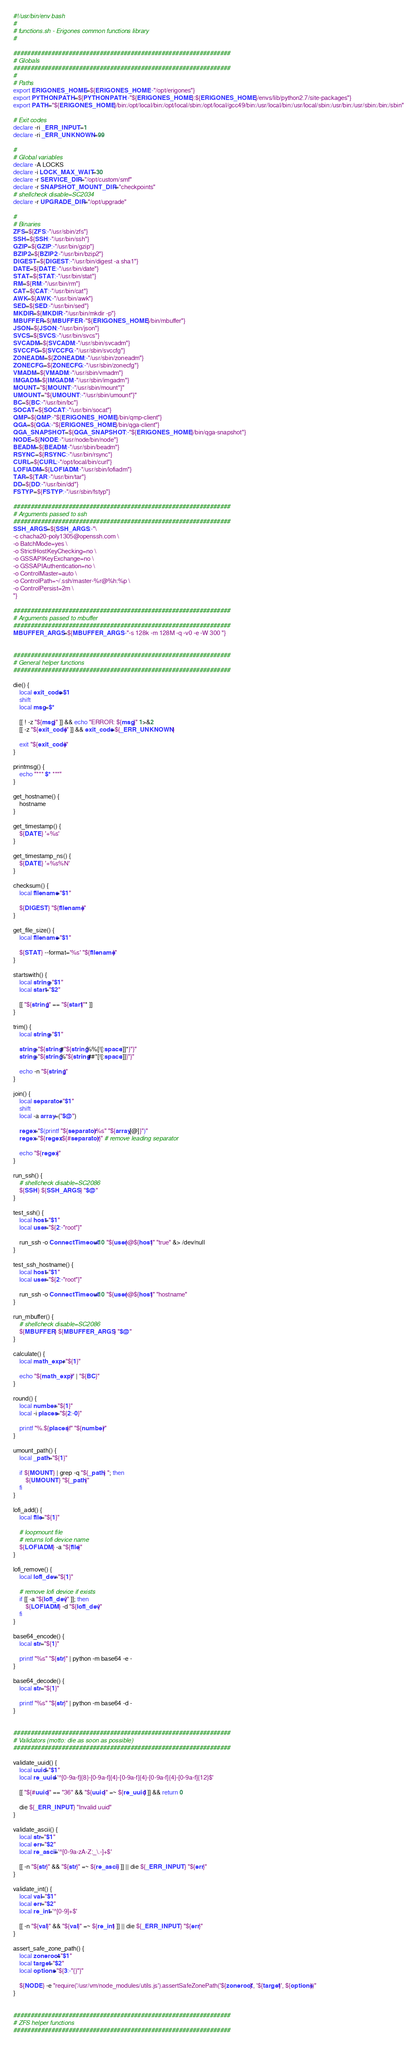<code> <loc_0><loc_0><loc_500><loc_500><_Bash_>#!/usr/bin/env bash
#
# functions.sh - Erigones common functions library
#

###############################################################
# Globals
###############################################################
#
# Paths
export ERIGONES_HOME=${ERIGONES_HOME:-"/opt/erigones"}
export PYTHONPATH=${PYTHONPATH:-"${ERIGONES_HOME}:${ERIGONES_HOME}/envs/lib/python2.7/site-packages"}
export PATH="${ERIGONES_HOME}/bin:/opt/local/bin:/opt/local/sbin:/opt/local/gcc49/bin:/usr/local/bin:/usr/local/sbin:/usr/bin:/usr/sbin:/bin:/sbin"

# Exit codes
declare -ri _ERR_INPUT=1
declare -ri _ERR_UNKNOWN=99

#
# Global variables
declare -A LOCKS
declare -i LOCK_MAX_WAIT=30
declare -r SERVICE_DIR="/opt/custom/smf"
declare -r SNAPSHOT_MOUNT_DIR="checkpoints"
# shellcheck disable=SC2034
declare -r UPGRADE_DIR="/opt/upgrade"

#
# Binaries
ZFS=${ZFS:-"/usr/sbin/zfs"}
SSH=${SSH:-"/usr/bin/ssh"}
GZIP=${GZIP:-"/usr/bin/gzip"}
BZIP2=${BZIP2:-"/usr/bin/bzip2"}
DIGEST=${DIGEST:-"/usr/bin/digest -a sha1"}
DATE=${DATE:-"/usr/bin/date"}
STAT=${STAT:-"/usr/bin/stat"}
RM=${RM:-"/usr/bin/rm"}
CAT=${CAT:-"/usr/bin/cat"}
AWK=${AWK:-"/usr/bin/awk"}
SED=${SED:-"/usr/bin/sed"}
MKDIR=${MKDIR:-"/usr/bin/mkdir -p"}
MBUFFER=${MBUFFER:-"${ERIGONES_HOME}/bin/mbuffer"}
JSON=${JSON:-"/usr/bin/json"}
SVCS=${SVCS:-"/usr/bin/svcs"}
SVCADM=${SVCADM:-"/usr/sbin/svcadm"}
SVCCFG=${SVCCFG:-"/usr/sbin/svccfg"}
ZONEADM=${ZONEADM:-"/usr/sbin/zoneadm"}
ZONECFG=${ZONECFG:-"/usr/sbin/zonecfg"}
VMADM=${VMADM:-"/usr/sbin/vmadm"}
IMGADM=${IMGADM:-"/usr/sbin/imgadm"}
MOUNT="${MOUNT:-"/usr/sbin/mount"}"
UMOUNT="${UMOUNT:-"/usr/sbin/umount"}"
BC=${BC:-"/usr/bin/bc"}
SOCAT=${SOCAT:-"/usr/bin/socat"}
QMP=${QMP:-"${ERIGONES_HOME}/bin/qmp-client"}
QGA=${QGA:-"${ERIGONES_HOME}/bin/qga-client"}
QGA_SNAPSHOT=${QGA_SNAPSHOT:-"${ERIGONES_HOME}/bin/qga-snapshot"}
NODE=${NODE:-"/usr/node/bin/node"}
BEADM=${BEADM:-"/usr/sbin/beadm"}
RSYNC=${RSYNC:-"/usr/bin/rsync"}
CURL=${CURL:-"/opt/local/bin/curl"}
LOFIADM=${LOFIADM:-"/usr/sbin/lofiadm"}
TAR=${TAR:-"/usr/bin/tar"}
DD=${DD:-"/usr/bin/dd"}
FSTYP=${FSTYP:-"/usr/sbin/fstyp"}

###############################################################
# Arguments passed to ssh
###############################################################
SSH_ARGS=${SSH_ARGS:-"\
-c chacha20-poly1305@openssh.com \
-o BatchMode=yes \
-o StrictHostKeyChecking=no \
-o GSSAPIKeyExchange=no \
-o GSSAPIAuthentication=no \
-o ControlMaster=auto \
-o ControlPath=~/.ssh/master-%r@%h:%p \
-o ControlPersist=2m \
"}

###############################################################
# Arguments passed to mbuffer
###############################################################
MBUFFER_ARGS=${MBUFFER_ARGS:-"-s 128k -m 128M -q -v0 -e -W 300 "}


###############################################################
# General helper functions
###############################################################

die() {
	local exit_code=$1
	shift
	local msg=$*

	[[ ! -z "${msg}" ]] && echo "ERROR: ${msg}" 1>&2
	[[ -z "${exit_code}" ]] && exit_code=${_ERR_UNKNOWN}

	exit "${exit_code}"
}

printmsg() {
	echo "*** $* ***"
}

get_hostname() {
	hostname
}

get_timestamp() {
	${DATE} '+%s'
}

get_timestamp_ns() {
	${DATE} '+%s%N'
}

checksum() {
	local filename="$1"

	${DIGEST} "${filename}"
}

get_file_size() {
	local filename="$1"

	${STAT} --format='%s' "${filename}"
}

startswith() {
	local string="$1"
	local start="$2"

	[[ "${string}" == "${start}"* ]]
}

trim() {
	local string="$1"

	string="${string#"${string%%[![:space:]]*}"}"
	string="${string%"${string##*[![:space:]]}"}"

	echo -n "${string}"
}

join() {
	local separator="$1"
	shift
	local -a array=("$@")

	regex="$(printf "${separator}%s" "${array[@]}")"
	regex="${regex:${#separator}}" # remove leading separator

	echo "${regex}"
}

run_ssh() {
	# shellcheck disable=SC2086
	${SSH} ${SSH_ARGS} "$@"
}

test_ssh() {
	local host="$1"
	local user="${2:-"root"}"

	run_ssh -o ConnectTimeout=10 "${user}@${host}" "true" &> /dev/null
}

test_ssh_hostname() {
	local host="$1"
	local user="${2:-"root"}"

	run_ssh -o ConnectTimeout=10 "${user}@${host}" "hostname"
}

run_mbuffer() {
	# shellcheck disable=SC2086
	${MBUFFER} ${MBUFFER_ARGS} "$@"
}

calculate() {
	local math_expr="${1}"

	echo "${math_expr}" | "${BC}"
}

round() {
	local number="${1}"
	local -i places="${2:-0}"

	printf "%.${places}f" "${number}"
}

umount_path() {
	local _path="${1}"

	if ${MOUNT} | grep -q "${_path} "; then
		${UMOUNT} "${_path}"
	fi
}

lofi_add() {
	local file="${1}"

	# loopmount file
	# returns lofi device name
	${LOFIADM} -a "${file}"
}

lofi_remove() {
	local lofi_dev="${1}"

	# remove lofi device if exists
	if [[ -a "${lofi_dev}" ]]; then
		${LOFIADM} -d "${lofi_dev}"
	fi
}

base64_encode() {
	local str="${1}"

	printf "%s" "${str}" | python -m base64 -e -
}

base64_decode() {
	local str="${1}"

	printf "%s" "${str}" | python -m base64 -d -
}


###############################################################
# Validators (motto: die as soon as possible)
###############################################################

validate_uuid() {  
	local uuid="$1"
	local re_uuid='^[0-9a-f]{8}-[0-9a-f]{4}-[0-9a-f]{4}-[0-9a-f]{4}-[0-9a-f]{12}$'

	[[ "${#uuid}" == "36" && "${uuid}" =~ ${re_uuid} ]] && return 0

	die ${_ERR_INPUT} "Invalid uuid"
}

validate_ascii() {
	local str="$1"
	local err="$2"
	local re_ascii='^[0-9a-zA-Z:_\.-]+$'

	[[ -n "${str}" && "${str}" =~ ${re_ascii} ]] || die ${_ERR_INPUT} "${err}"
}

validate_int() {
	local val="$1"
	local err="$2"
	local re_int='^[0-9]+$'

	[[ -n "${val}" && "${val}" =~ ${re_int} ]] || die ${_ERR_INPUT} "${err}"
}

assert_safe_zone_path() {
	local zoneroot="$1"
	local target="$2"
	local options="${3:-"{}"}"

	${NODE} -e "require('/usr/vm/node_modules/utils.js').assertSafeZonePath('${zoneroot}', '${target}', ${options})"
}


###############################################################
# ZFS helper functions
###############################################################
</code> 